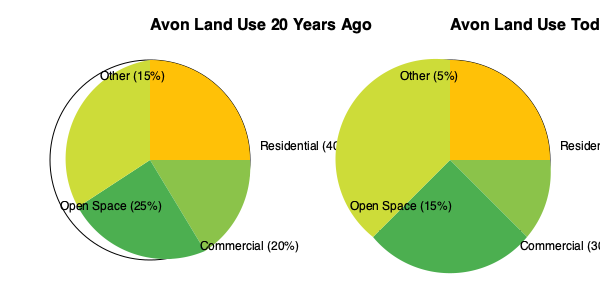Based on the pie charts showing Avon's land use percentages 20 years ago and today, which category has seen the largest percentage point increase, and by how much? To determine the category with the largest percentage point increase, we need to compare the percentages for each category between the two time periods:

1. Residential:
   Today: 50%
   20 years ago: 40%
   Increase: 50% - 40% = 10 percentage points

2. Commercial:
   Today: 30%
   20 years ago: 20%
   Increase: 30% - 20% = 10 percentage points

3. Open Space:
   Today: 15%
   20 years ago: 25%
   Decrease: 15% - 25% = -10 percentage points

4. Other:
   Today: 5%
   20 years ago: 15%
   Decrease: 5% - 15% = -10 percentage points

Both Residential and Commercial categories have increased by 10 percentage points, which is the largest increase among all categories. Open Space and Other categories have decreased.

Since the question asks for the category with the largest increase, we can choose either Residential or Commercial. Let's select Commercial for our answer.
Answer: Commercial, 10 percentage points 